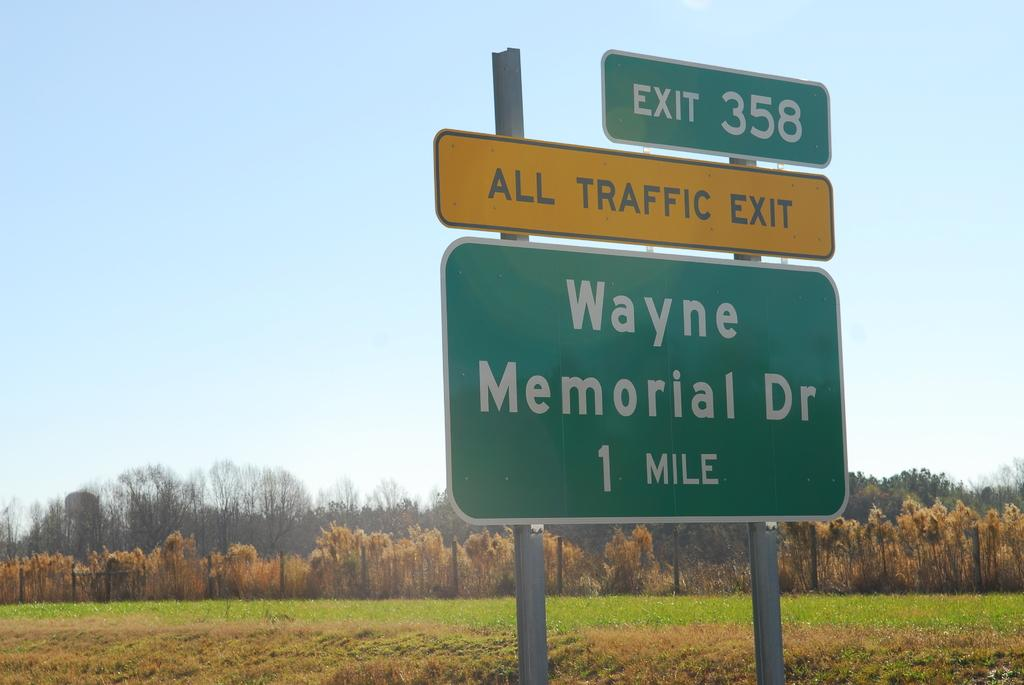<image>
Present a compact description of the photo's key features. many signs that have all traffic exit on it 